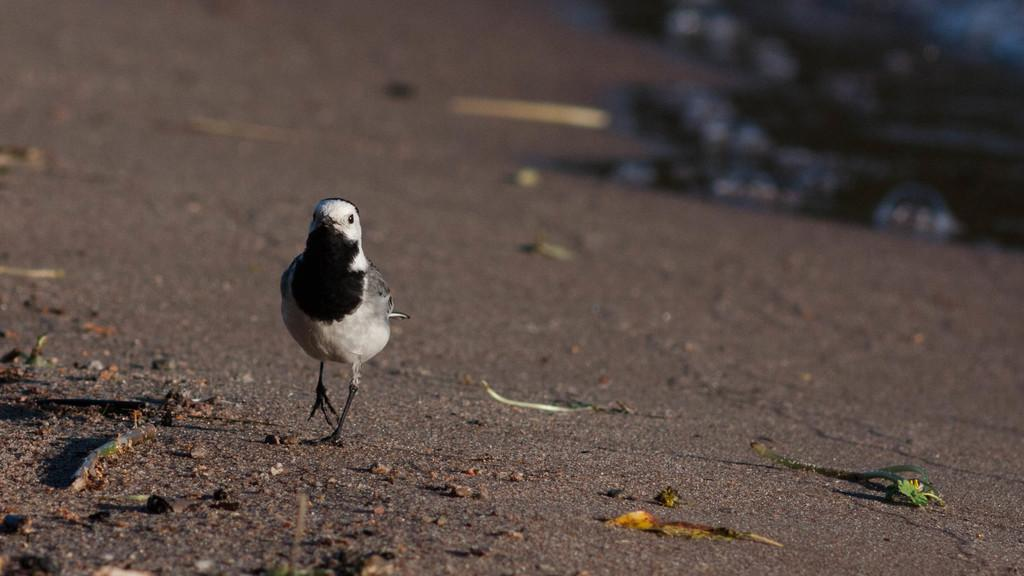What type of animal can be seen on the left side of the image? There is a bird on the left side of the image. What color combination does the bird have? The bird has a black and white color combination. What is the bird doing in the image? The bird is walking on the road. What can be found on the road in the image? The road contains sticks, leaves, and stones. How would you describe the background of the image? The background of the image is blurred. Can you tell me how many bones the bird is carrying in the image? There is no indication in the image that the bird is carrying any bones. 